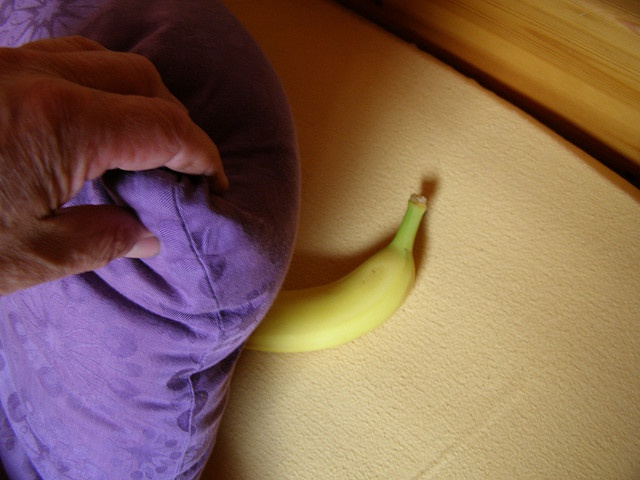Describe the objects in this image and their specific colors. I can see people in purple, maroon, and brown tones and banana in purple, khaki, olive, and maroon tones in this image. 